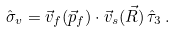<formula> <loc_0><loc_0><loc_500><loc_500>\hat { \sigma } _ { v } = \vec { v } _ { f } ( \vec { p } _ { f } ) \cdot \vec { v } _ { s } ( \vec { R } ) \, \hat { \tau } _ { 3 } \, .</formula> 